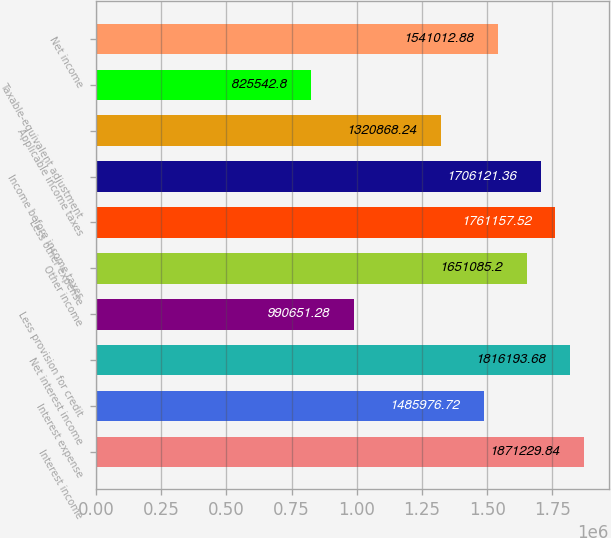<chart> <loc_0><loc_0><loc_500><loc_500><bar_chart><fcel>Interest income<fcel>Interest expense<fcel>Net interest income<fcel>Less provision for credit<fcel>Other income<fcel>Less other expense<fcel>Income before income taxes<fcel>Applicable income taxes<fcel>Taxable-equivalent adjustment<fcel>Net income<nl><fcel>1.87123e+06<fcel>1.48598e+06<fcel>1.81619e+06<fcel>990651<fcel>1.65109e+06<fcel>1.76116e+06<fcel>1.70612e+06<fcel>1.32087e+06<fcel>825543<fcel>1.54101e+06<nl></chart> 